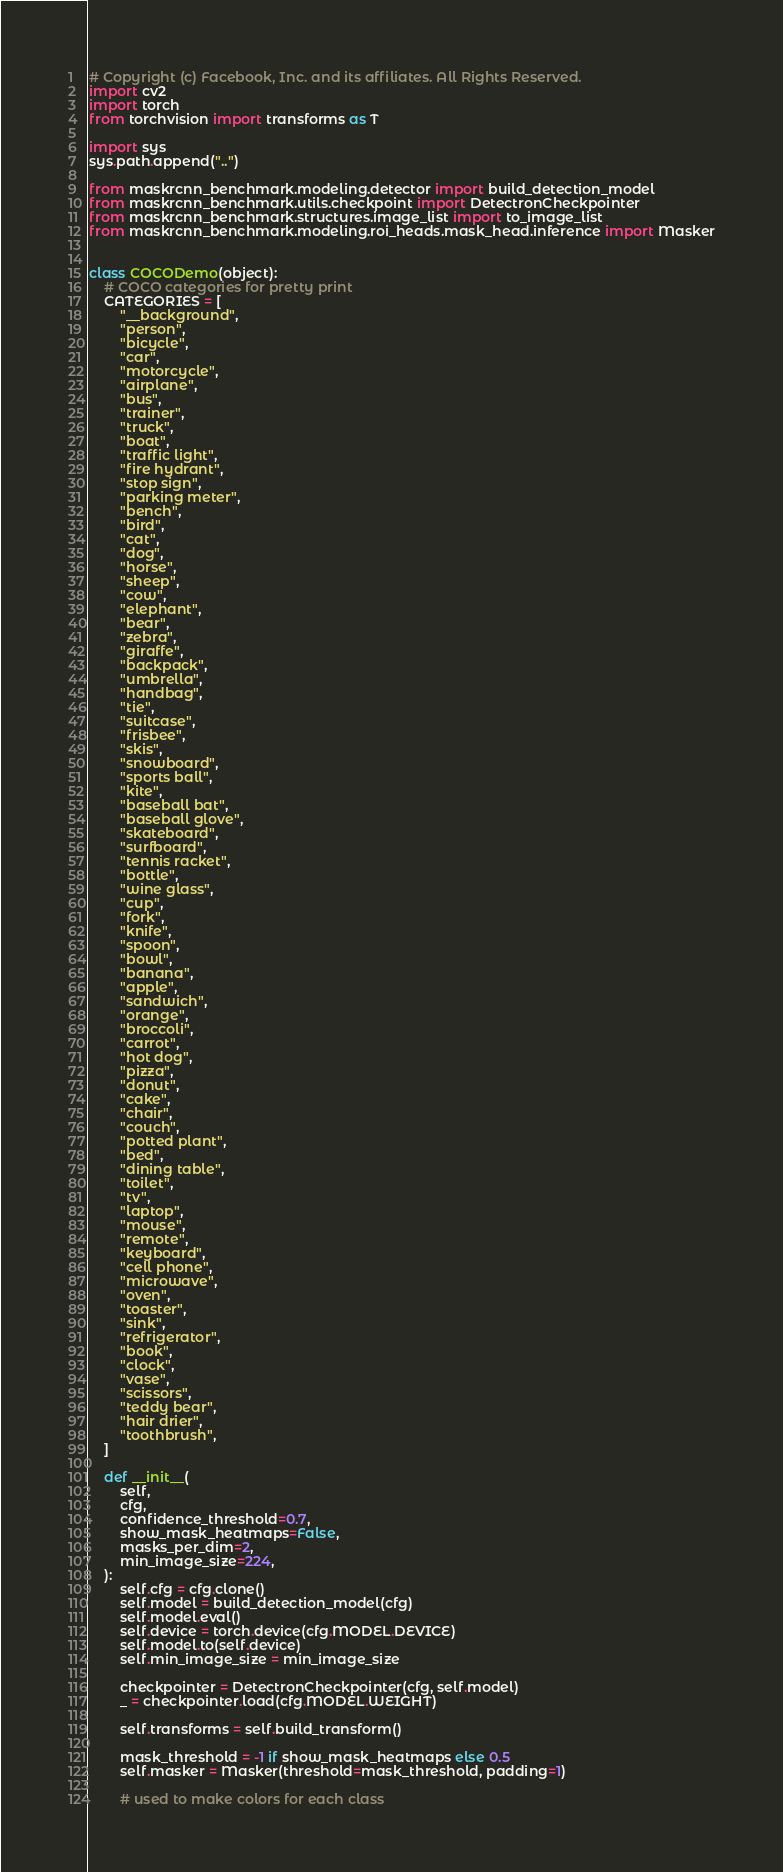<code> <loc_0><loc_0><loc_500><loc_500><_Python_># Copyright (c) Facebook, Inc. and its affiliates. All Rights Reserved.
import cv2
import torch
from torchvision import transforms as T

import sys
sys.path.append("..")

from maskrcnn_benchmark.modeling.detector import build_detection_model
from maskrcnn_benchmark.utils.checkpoint import DetectronCheckpointer
from maskrcnn_benchmark.structures.image_list import to_image_list
from maskrcnn_benchmark.modeling.roi_heads.mask_head.inference import Masker


class COCODemo(object):
    # COCO categories for pretty print
    CATEGORIES = [
        "__background",
        "person",
        "bicycle",
        "car",
        "motorcycle",
        "airplane",
        "bus",
        "trainer",
        "truck",
        "boat",
        "traffic light",
        "fire hydrant",
        "stop sign",
        "parking meter",
        "bench",
        "bird",
        "cat",
        "dog",
        "horse",
        "sheep",
        "cow",
        "elephant",
        "bear",
        "zebra",
        "giraffe",
        "backpack",
        "umbrella",
        "handbag",
        "tie",
        "suitcase",
        "frisbee",
        "skis",
        "snowboard",
        "sports ball",
        "kite",
        "baseball bat",
        "baseball glove",
        "skateboard",
        "surfboard",
        "tennis racket",
        "bottle",
        "wine glass",
        "cup",
        "fork",
        "knife",
        "spoon",
        "bowl",
        "banana",
        "apple",
        "sandwich",
        "orange",
        "broccoli",
        "carrot",
        "hot dog",
        "pizza",
        "donut",
        "cake",
        "chair",
        "couch",
        "potted plant",
        "bed",
        "dining table",
        "toilet",
        "tv",
        "laptop",
        "mouse",
        "remote",
        "keyboard",
        "cell phone",
        "microwave",
        "oven",
        "toaster",
        "sink",
        "refrigerator",
        "book",
        "clock",
        "vase",
        "scissors",
        "teddy bear",
        "hair drier",
        "toothbrush",
    ]

    def __init__(
        self,
        cfg,
        confidence_threshold=0.7,
        show_mask_heatmaps=False,
        masks_per_dim=2,
        min_image_size=224,
    ):
        self.cfg = cfg.clone()
        self.model = build_detection_model(cfg)
        self.model.eval()
        self.device = torch.device(cfg.MODEL.DEVICE)
        self.model.to(self.device)
        self.min_image_size = min_image_size

        checkpointer = DetectronCheckpointer(cfg, self.model)
        _ = checkpointer.load(cfg.MODEL.WEIGHT)

        self.transforms = self.build_transform()

        mask_threshold = -1 if show_mask_heatmaps else 0.5
        self.masker = Masker(threshold=mask_threshold, padding=1)

        # used to make colors for each class</code> 